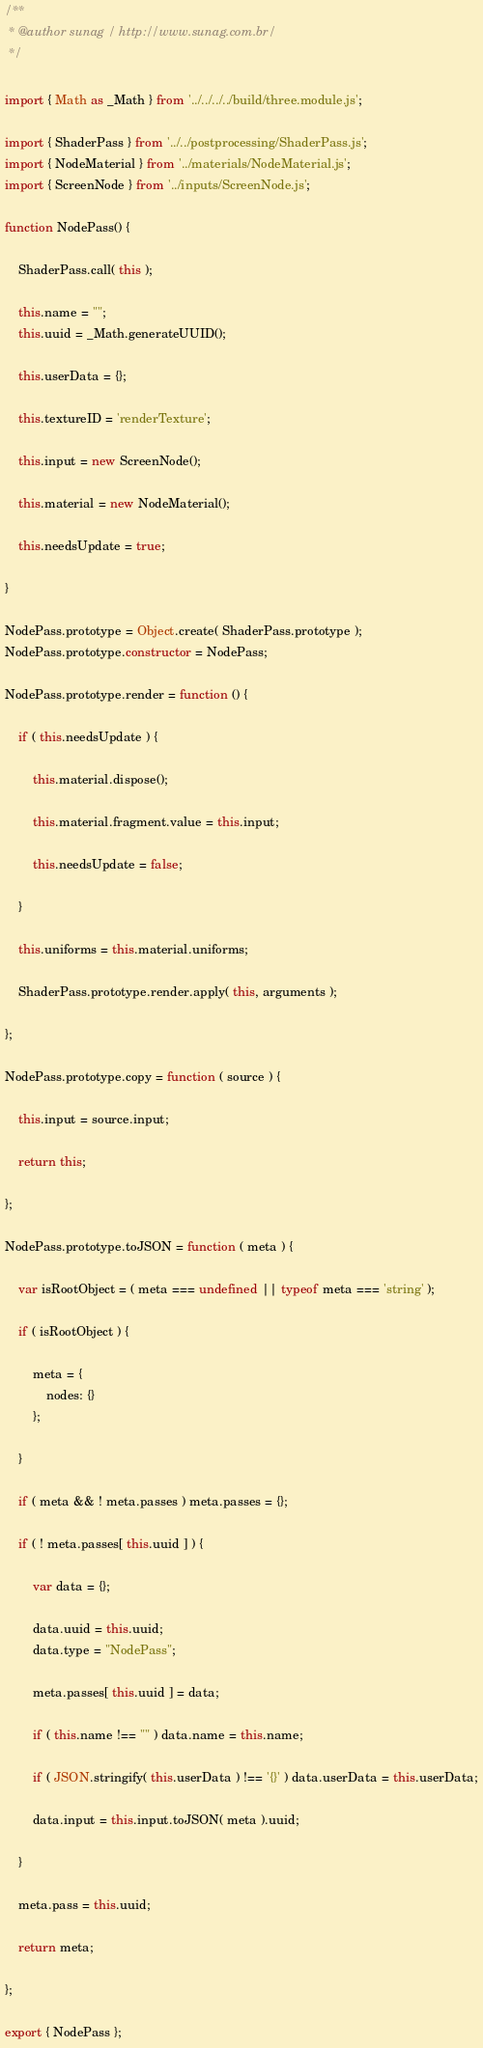<code> <loc_0><loc_0><loc_500><loc_500><_JavaScript_>/**
 * @author sunag / http://www.sunag.com.br/
 */

import { Math as _Math } from '../../../../build/three.module.js';

import { ShaderPass } from '../../postprocessing/ShaderPass.js';
import { NodeMaterial } from '../materials/NodeMaterial.js';
import { ScreenNode } from '../inputs/ScreenNode.js';

function NodePass() {

	ShaderPass.call( this );

	this.name = "";
	this.uuid = _Math.generateUUID();

	this.userData = {};

	this.textureID = 'renderTexture';

	this.input = new ScreenNode();

	this.material = new NodeMaterial();

	this.needsUpdate = true;

}

NodePass.prototype = Object.create( ShaderPass.prototype );
NodePass.prototype.constructor = NodePass;

NodePass.prototype.render = function () {

	if ( this.needsUpdate ) {

		this.material.dispose();

		this.material.fragment.value = this.input;

		this.needsUpdate = false;

	}

	this.uniforms = this.material.uniforms;

	ShaderPass.prototype.render.apply( this, arguments );

};

NodePass.prototype.copy = function ( source ) {

	this.input = source.input;

	return this;

};

NodePass.prototype.toJSON = function ( meta ) {

	var isRootObject = ( meta === undefined || typeof meta === 'string' );

	if ( isRootObject ) {

		meta = {
			nodes: {}
		};

	}

	if ( meta && ! meta.passes ) meta.passes = {};

	if ( ! meta.passes[ this.uuid ] ) {

		var data = {};

		data.uuid = this.uuid;
		data.type = "NodePass";

		meta.passes[ this.uuid ] = data;

		if ( this.name !== "" ) data.name = this.name;

		if ( JSON.stringify( this.userData ) !== '{}' ) data.userData = this.userData;

		data.input = this.input.toJSON( meta ).uuid;

	}

	meta.pass = this.uuid;

	return meta;

};

export { NodePass };
</code> 